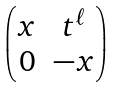Convert formula to latex. <formula><loc_0><loc_0><loc_500><loc_500>\begin{pmatrix} x & t ^ { \ell } \\ 0 & - x \end{pmatrix}</formula> 